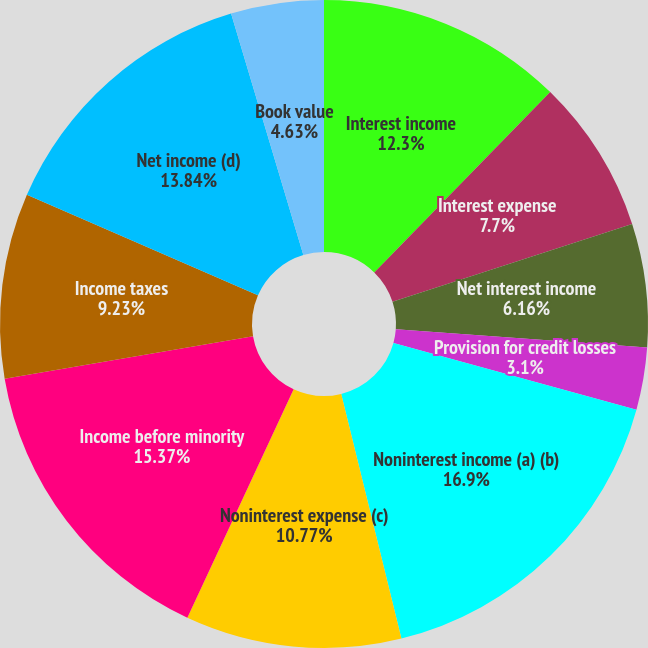<chart> <loc_0><loc_0><loc_500><loc_500><pie_chart><fcel>Interest income<fcel>Interest expense<fcel>Net interest income<fcel>Provision for credit losses<fcel>Noninterest income (a) (b)<fcel>Noninterest expense (c)<fcel>Income before minority<fcel>Income taxes<fcel>Net income (d)<fcel>Book value<nl><fcel>12.3%<fcel>7.7%<fcel>6.16%<fcel>3.1%<fcel>16.9%<fcel>10.77%<fcel>15.37%<fcel>9.23%<fcel>13.84%<fcel>4.63%<nl></chart> 